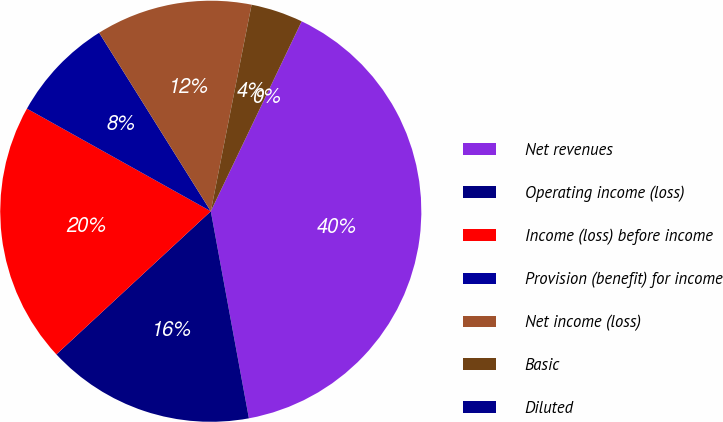Convert chart to OTSL. <chart><loc_0><loc_0><loc_500><loc_500><pie_chart><fcel>Net revenues<fcel>Operating income (loss)<fcel>Income (loss) before income<fcel>Provision (benefit) for income<fcel>Net income (loss)<fcel>Basic<fcel>Diluted<nl><fcel>40.0%<fcel>16.0%<fcel>20.0%<fcel>8.0%<fcel>12.0%<fcel>4.0%<fcel>0.0%<nl></chart> 